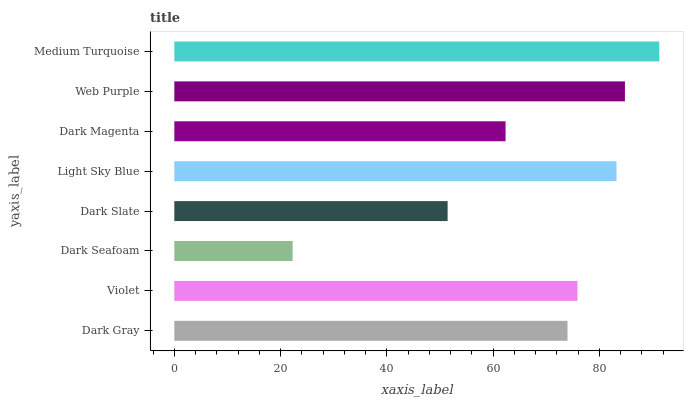Is Dark Seafoam the minimum?
Answer yes or no. Yes. Is Medium Turquoise the maximum?
Answer yes or no. Yes. Is Violet the minimum?
Answer yes or no. No. Is Violet the maximum?
Answer yes or no. No. Is Violet greater than Dark Gray?
Answer yes or no. Yes. Is Dark Gray less than Violet?
Answer yes or no. Yes. Is Dark Gray greater than Violet?
Answer yes or no. No. Is Violet less than Dark Gray?
Answer yes or no. No. Is Violet the high median?
Answer yes or no. Yes. Is Dark Gray the low median?
Answer yes or no. Yes. Is Dark Seafoam the high median?
Answer yes or no. No. Is Dark Slate the low median?
Answer yes or no. No. 